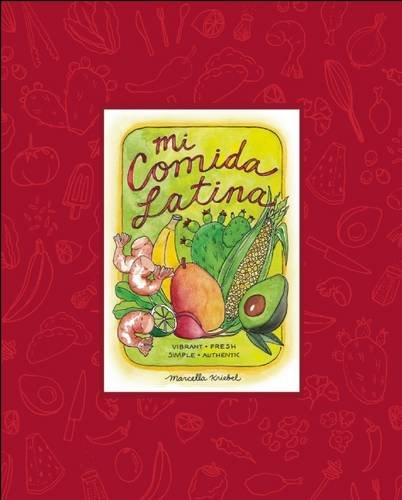What inspired Marcella Kriebel to write this book? Marcella Kriebel was inspired by her extensive travels across Latin America and her passion for connecting people through food, which led her to gather and share these exquisite, authentic recipes in 'Mi Comida Latina.' 